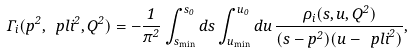<formula> <loc_0><loc_0><loc_500><loc_500>\Gamma _ { i } ( p ^ { 2 } , { \ p l i } ^ { 2 } , Q ^ { 2 } ) = - \frac { 1 } { \pi ^ { 2 } } \int _ { s _ { \min } } ^ { s _ { 0 } } d s \int _ { u _ { \min } } ^ { u _ { 0 } } d u \, \frac { \rho _ { i } ( s , u , Q ^ { 2 } ) } { ( s - p ^ { 2 } ) ( u - { \ p l i } ^ { 2 } ) } ,</formula> 